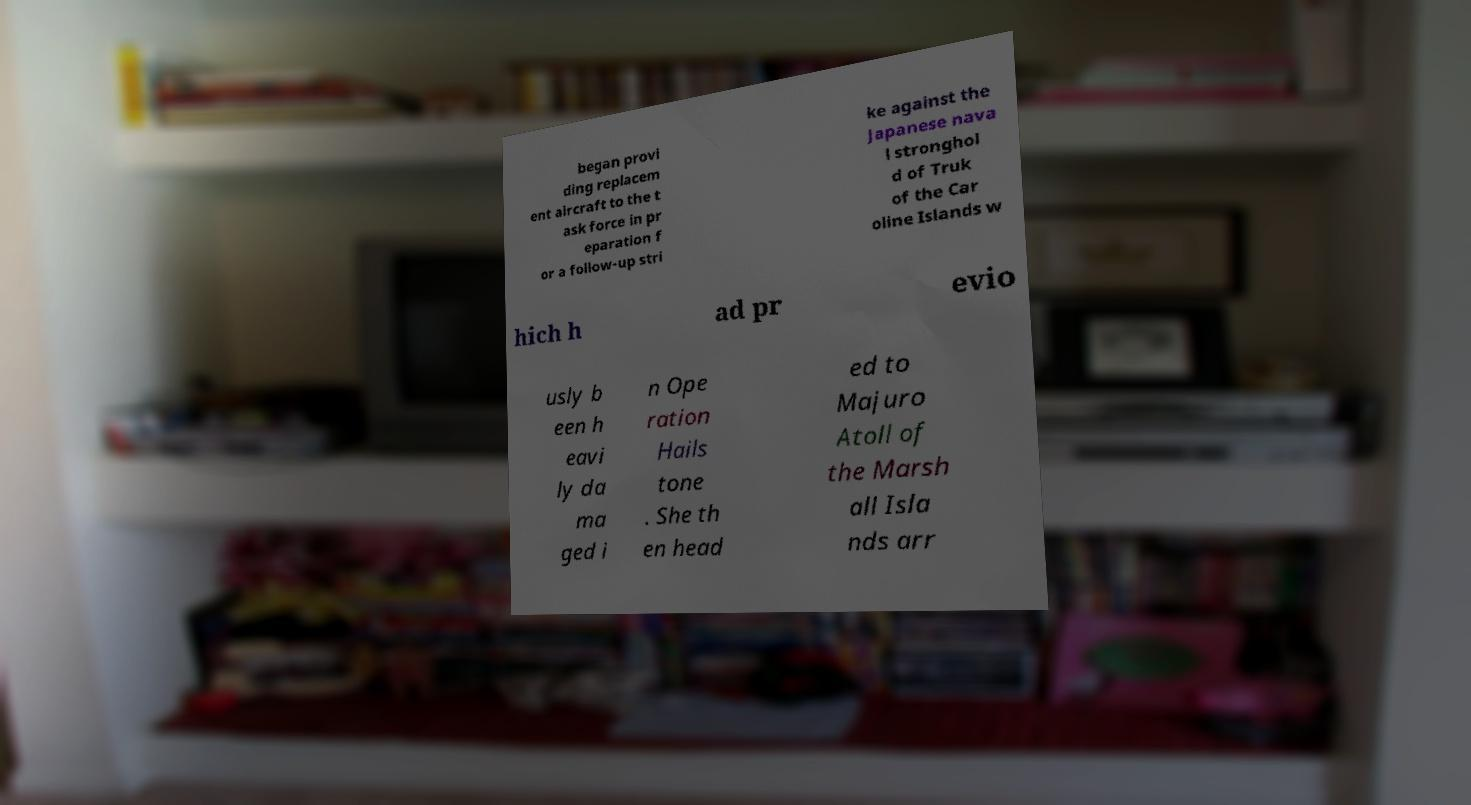There's text embedded in this image that I need extracted. Can you transcribe it verbatim? began provi ding replacem ent aircraft to the t ask force in pr eparation f or a follow-up stri ke against the Japanese nava l stronghol d of Truk of the Car oline Islands w hich h ad pr evio usly b een h eavi ly da ma ged i n Ope ration Hails tone . She th en head ed to Majuro Atoll of the Marsh all Isla nds arr 